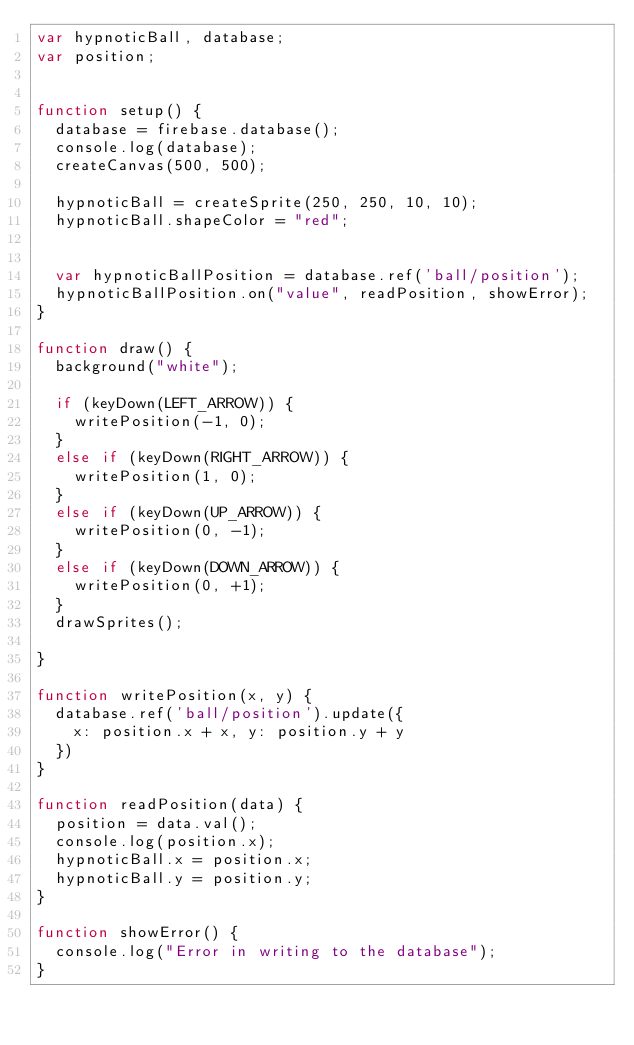<code> <loc_0><loc_0><loc_500><loc_500><_JavaScript_>var hypnoticBall, database;
var position;


function setup() {
  database = firebase.database();
  console.log(database);
  createCanvas(500, 500);

  hypnoticBall = createSprite(250, 250, 10, 10);
  hypnoticBall.shapeColor = "red";


  var hypnoticBallPosition = database.ref('ball/position');
  hypnoticBallPosition.on("value", readPosition, showError);
}

function draw() {
  background("white");

  if (keyDown(LEFT_ARROW)) {
    writePosition(-1, 0);
  }
  else if (keyDown(RIGHT_ARROW)) {
    writePosition(1, 0);
  }
  else if (keyDown(UP_ARROW)) {
    writePosition(0, -1);
  }
  else if (keyDown(DOWN_ARROW)) {
    writePosition(0, +1);
  }
  drawSprites();

}

function writePosition(x, y) {
  database.ref('ball/position').update({
    x: position.x + x, y: position.y + y
  })
}

function readPosition(data) {
  position = data.val();
  console.log(position.x);
  hypnoticBall.x = position.x;
  hypnoticBall.y = position.y;
}

function showError() {
  console.log("Error in writing to the database");
}
</code> 